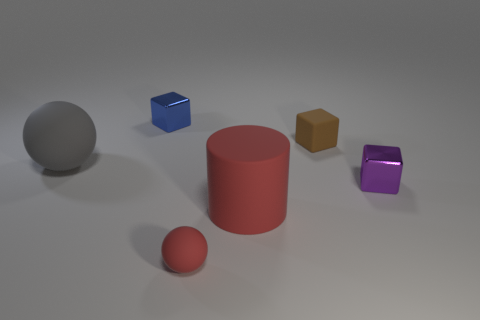Add 2 cyan matte cylinders. How many objects exist? 8 Subtract all spheres. How many objects are left? 4 Add 1 tiny blue matte cylinders. How many tiny blue matte cylinders exist? 1 Subtract 0 blue cylinders. How many objects are left? 6 Subtract all red matte spheres. Subtract all big gray spheres. How many objects are left? 4 Add 4 red things. How many red things are left? 6 